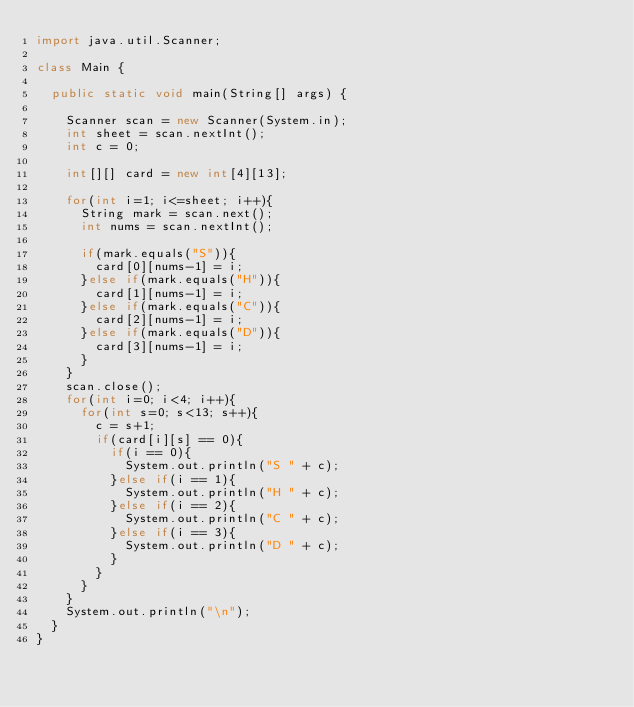<code> <loc_0><loc_0><loc_500><loc_500><_Java_>import java.util.Scanner;

class Main {

	public static void main(String[] args) {

		Scanner scan = new Scanner(System.in);
		int sheet = scan.nextInt();
		int c = 0;

		int[][] card = new int[4][13];

		for(int i=1; i<=sheet; i++){
			String mark = scan.next();
			int nums = scan.nextInt();

			if(mark.equals("S")){
				card[0][nums-1] = i;
			}else if(mark.equals("H")){
				card[1][nums-1] = i;
			}else if(mark.equals("C")){
				card[2][nums-1] = i;
			}else if(mark.equals("D")){
				card[3][nums-1] = i;
			}
		}
		scan.close();
		for(int i=0; i<4; i++){
			for(int s=0; s<13; s++){
				c = s+1;
				if(card[i][s] == 0){
					if(i == 0){
						System.out.println("S " + c);
					}else if(i == 1){
						System.out.println("H " + c);
					}else if(i == 2){
						System.out.println("C " + c);
					}else if(i == 3){
						System.out.println("D " + c);
					}
				}
			}
		}
		System.out.println("\n");
	}
}</code> 